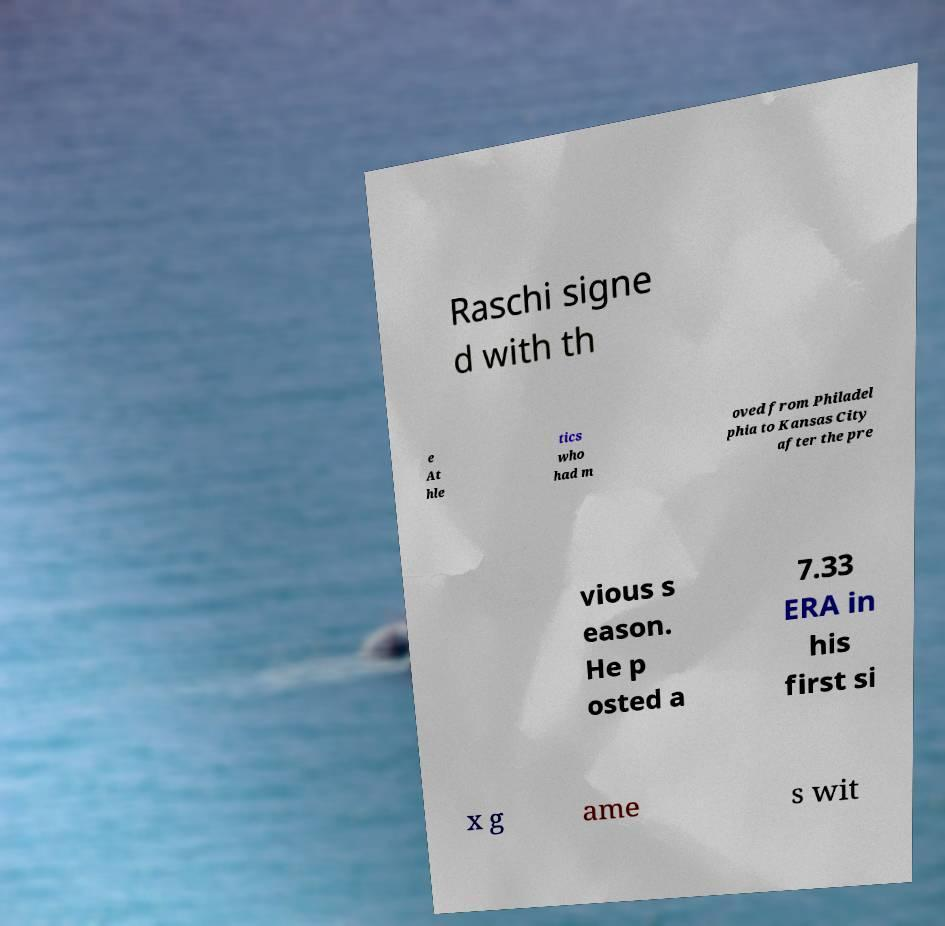For documentation purposes, I need the text within this image transcribed. Could you provide that? Raschi signe d with th e At hle tics who had m oved from Philadel phia to Kansas City after the pre vious s eason. He p osted a 7.33 ERA in his first si x g ame s wit 